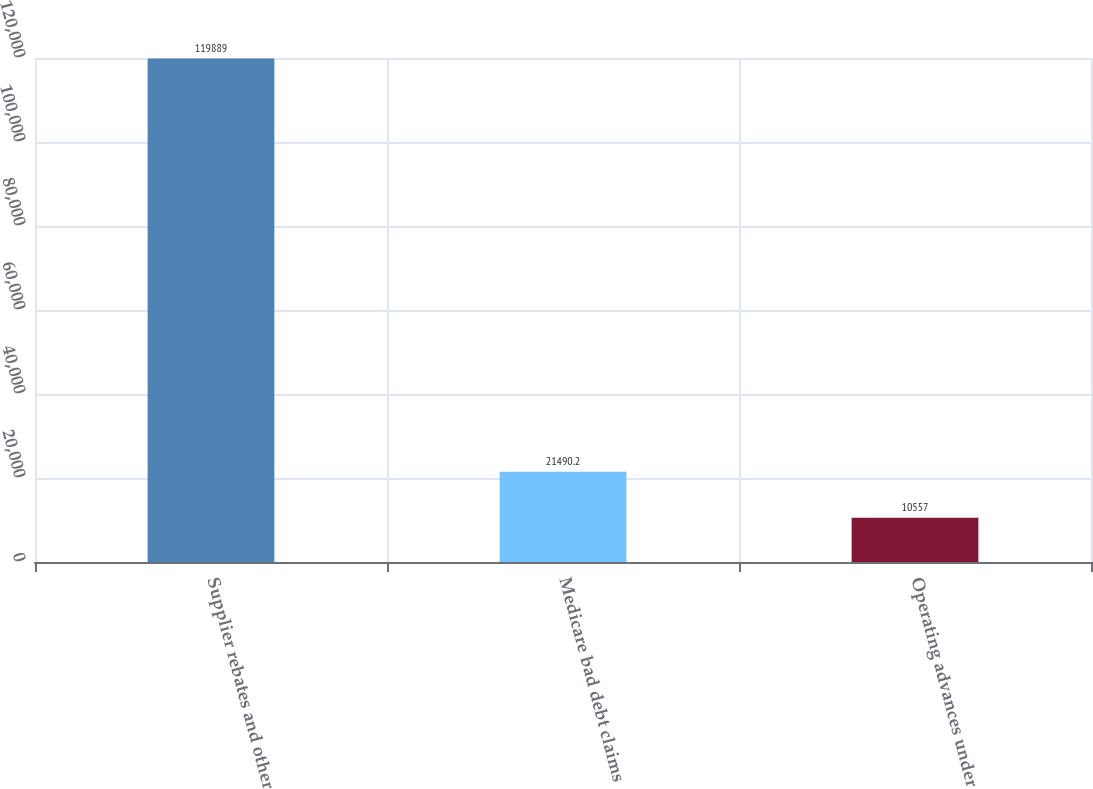Convert chart to OTSL. <chart><loc_0><loc_0><loc_500><loc_500><bar_chart><fcel>Supplier rebates and other<fcel>Medicare bad debt claims<fcel>Operating advances under<nl><fcel>119889<fcel>21490.2<fcel>10557<nl></chart> 